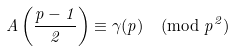Convert formula to latex. <formula><loc_0><loc_0><loc_500><loc_500>A \left ( \frac { p - 1 } { 2 } \right ) \equiv \gamma ( p ) \pmod { p ^ { 2 } }</formula> 